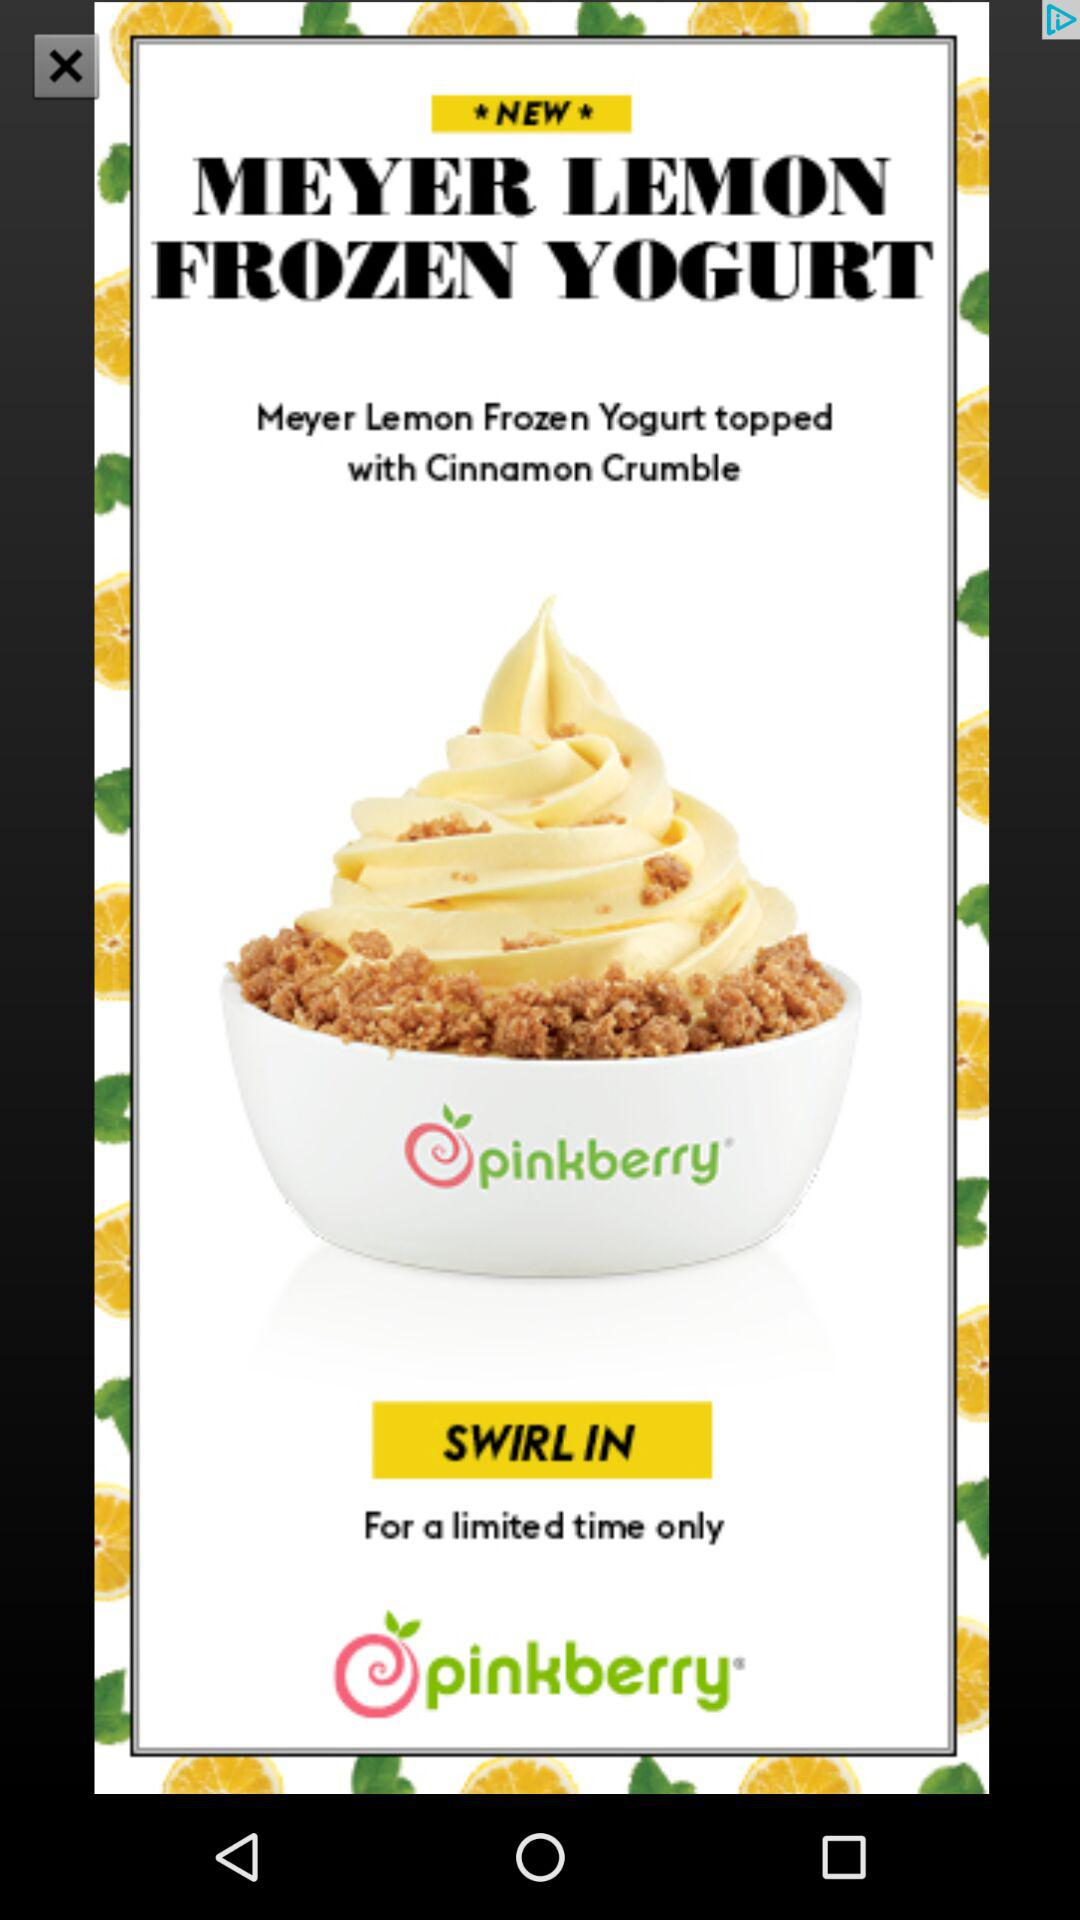How many pinkberry logos are there on the screen?
Answer the question using a single word or phrase. 2 